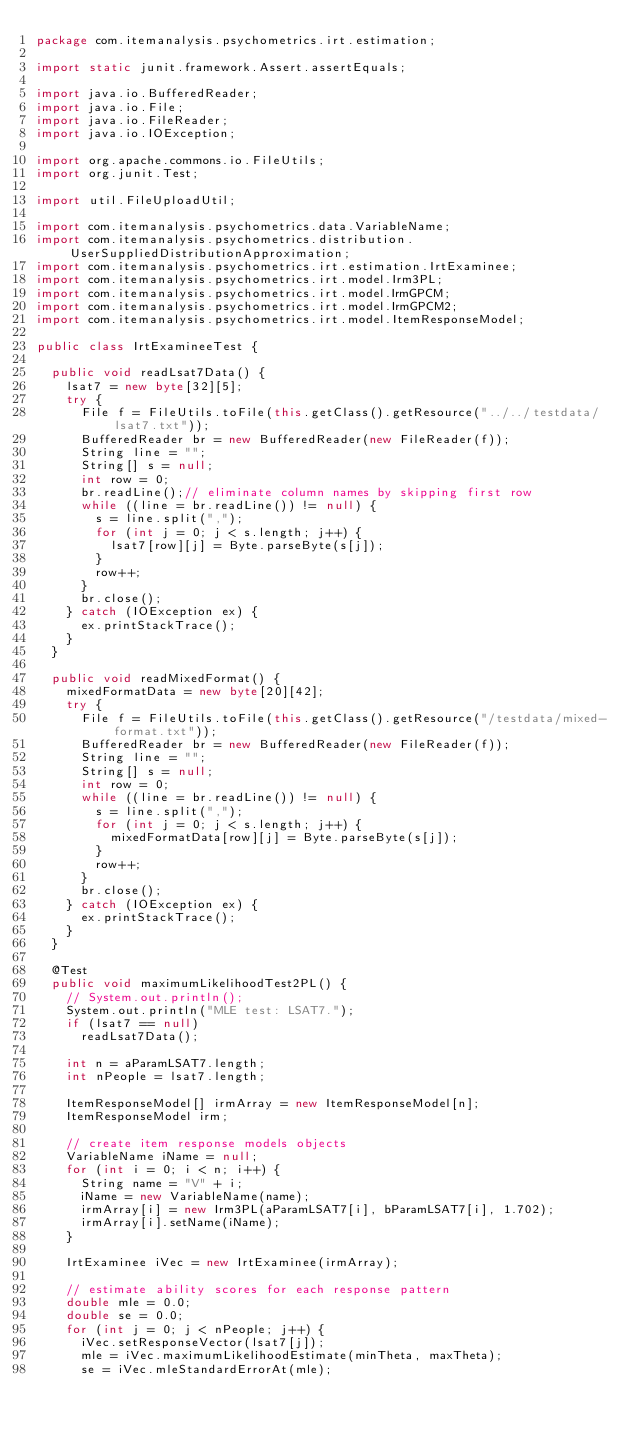<code> <loc_0><loc_0><loc_500><loc_500><_Java_>package com.itemanalysis.psychometrics.irt.estimation;

import static junit.framework.Assert.assertEquals;

import java.io.BufferedReader;
import java.io.File;
import java.io.FileReader;
import java.io.IOException;

import org.apache.commons.io.FileUtils;
import org.junit.Test;

import util.FileUploadUtil;

import com.itemanalysis.psychometrics.data.VariableName;
import com.itemanalysis.psychometrics.distribution.UserSuppliedDistributionApproximation;
import com.itemanalysis.psychometrics.irt.estimation.IrtExaminee;
import com.itemanalysis.psychometrics.irt.model.Irm3PL;
import com.itemanalysis.psychometrics.irt.model.IrmGPCM;
import com.itemanalysis.psychometrics.irt.model.IrmGPCM2;
import com.itemanalysis.psychometrics.irt.model.ItemResponseModel;

public class IrtExamineeTest {

	public void readLsat7Data() {
		lsat7 = new byte[32][5];
		try {
			File f = FileUtils.toFile(this.getClass().getResource("../../testdata/lsat7.txt"));
			BufferedReader br = new BufferedReader(new FileReader(f));
			String line = "";
			String[] s = null;
			int row = 0;
			br.readLine();// eliminate column names by skipping first row
			while ((line = br.readLine()) != null) {
				s = line.split(",");
				for (int j = 0; j < s.length; j++) {
					lsat7[row][j] = Byte.parseByte(s[j]);
				}
				row++;
			}
			br.close();
		} catch (IOException ex) {
			ex.printStackTrace();
		}
	}

	public void readMixedFormat() {
		mixedFormatData = new byte[20][42];
		try {
			File f = FileUtils.toFile(this.getClass().getResource("/testdata/mixed-format.txt"));
			BufferedReader br = new BufferedReader(new FileReader(f));
			String line = "";
			String[] s = null;
			int row = 0;
			while ((line = br.readLine()) != null) {
				s = line.split(",");
				for (int j = 0; j < s.length; j++) {
					mixedFormatData[row][j] = Byte.parseByte(s[j]);
				}
				row++;
			}
			br.close();
		} catch (IOException ex) {
			ex.printStackTrace();
		}
	}

	@Test
	public void maximumLikelihoodTest2PL() {
		// System.out.println();
		System.out.println("MLE test: LSAT7.");
		if (lsat7 == null)
			readLsat7Data();

		int n = aParamLSAT7.length;
		int nPeople = lsat7.length;

		ItemResponseModel[] irmArray = new ItemResponseModel[n];
		ItemResponseModel irm;

		// create item response models objects
		VariableName iName = null;
		for (int i = 0; i < n; i++) {
			String name = "V" + i;
			iName = new VariableName(name);
			irmArray[i] = new Irm3PL(aParamLSAT7[i], bParamLSAT7[i], 1.702);
			irmArray[i].setName(iName);
		}

		IrtExaminee iVec = new IrtExaminee(irmArray);

		// estimate ability scores for each response pattern
		double mle = 0.0;
		double se = 0.0;
		for (int j = 0; j < nPeople; j++) {
			iVec.setResponseVector(lsat7[j]);
			mle = iVec.maximumLikelihoodEstimate(minTheta, maxTheta);
			se = iVec.mleStandardErrorAt(mle);</code> 